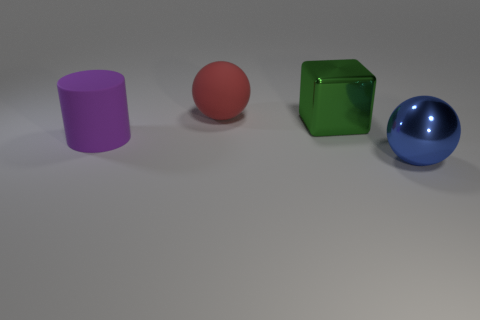Add 4 matte cylinders. How many objects exist? 8 Subtract all cylinders. How many objects are left? 3 Subtract 0 yellow cylinders. How many objects are left? 4 Subtract all large green rubber objects. Subtract all large cubes. How many objects are left? 3 Add 1 blue metal spheres. How many blue metal spheres are left? 2 Add 3 big cyan shiny cylinders. How many big cyan shiny cylinders exist? 3 